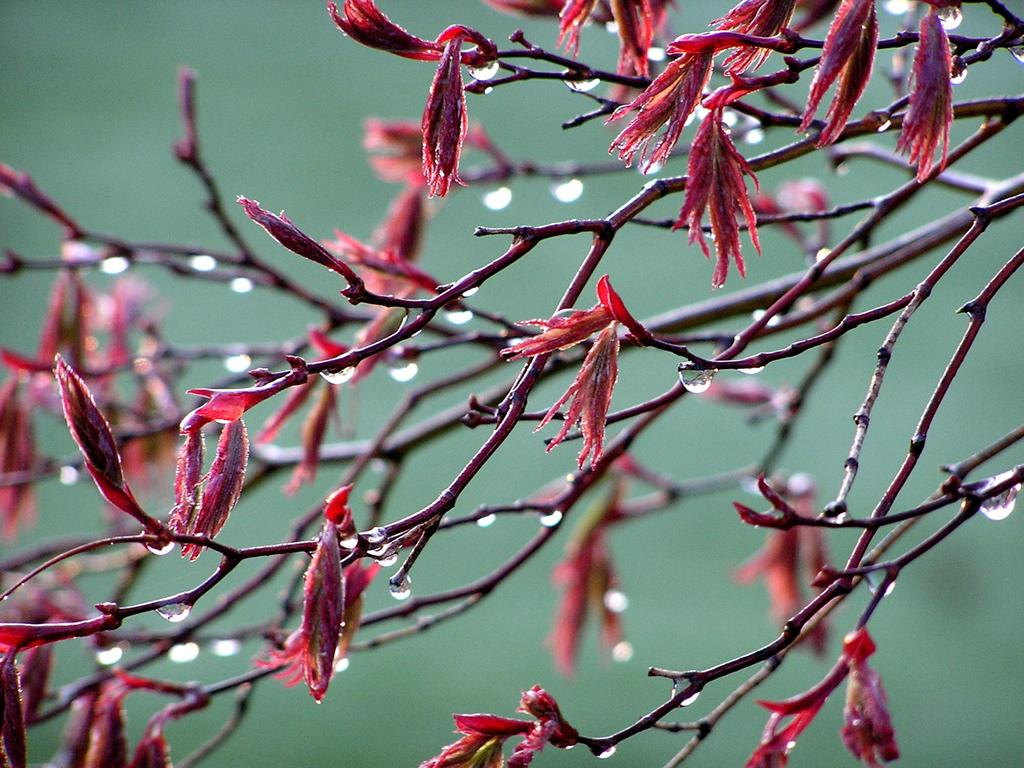What is the main subject of the image? The main subject of the image is a tree. What can be observed on the tree? The tree has flowers and buds. What color is the background of the image? The background of the image is green. Reasoning: Let'ing: Let's think step by step in order to produce the conversation. We start by identifying the main subject of the image, which is the tree. Then, we describe the specific features of the tree, such as the flowers and buds. Finally, we mention the color of the background, which is green. Each question is designed to elicit a specific detail about the image that is known from the provided facts. Absurd Question/Answer: What month is it in the image? The month cannot be determined from the image, as there is no information about the time of year. Is there a crib visible in the image? No, there is no crib present in the image. 